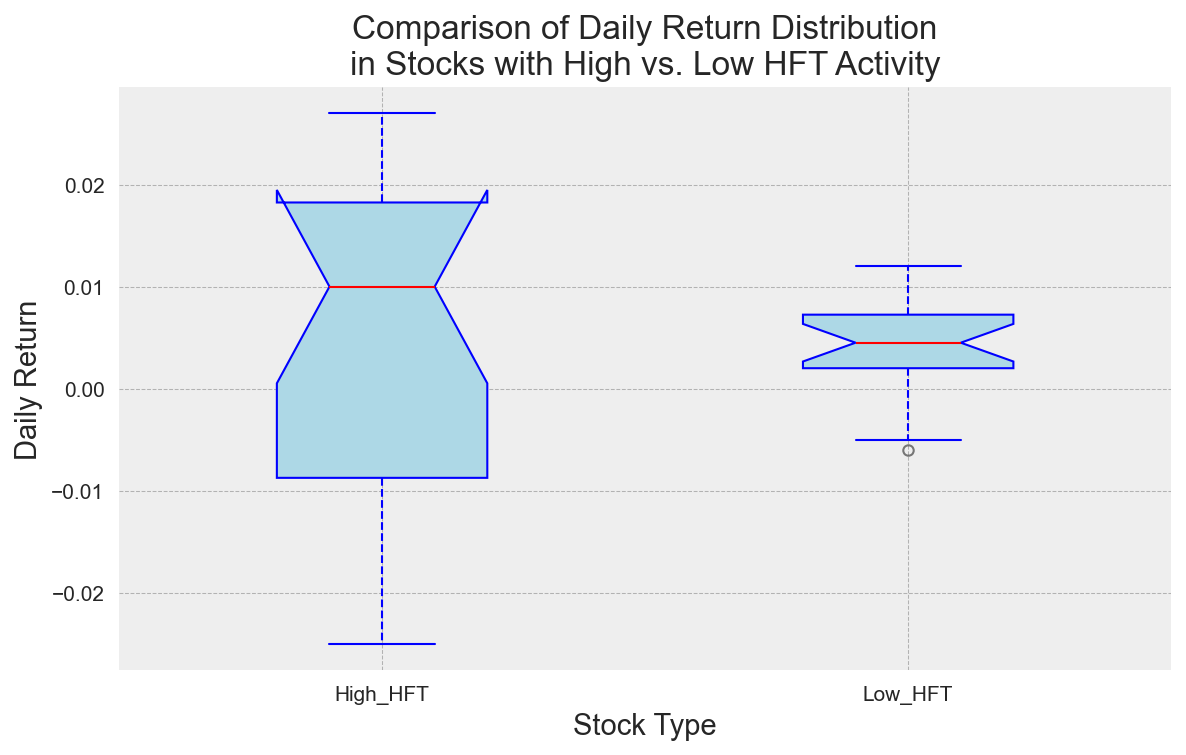What is the median daily return for stocks with high HFT activity? To determine the median daily return for stocks with high HFT activity, look at the red line within the box plot for "High HFT" stocks.
Answer: Around 0.014 Which stock type has a higher interquartile range (IQR) of daily returns? To find which stock type has a higher IQR, compare the height of the blue boxes. The IQR is the range between the bottom (25th percentile) and top (75th percentile) of the box.
Answer: High HFT What is the range of daily returns for stocks with low HFT activity? The range is determined by the minimum and maximum values represented by the tops and bottoms of the whiskers for the "Low HFT" stocks.
Answer: -0.006 to 0.012 Are there any outliers in the daily returns for stocks with high HFT activity? Look for points outside the whiskers for the "High HFT" box plot, marked by orange circles.
Answer: Yes How do the median daily returns compare between high and low HFT activity stocks? Observe the position of the red lines inside the boxes for both "High HFT" and "Low HFT" stocks.
Answer: Median is higher in High HFT What is the approximate median daily return for stocks with low HFT activity? Look at the red line inside the "Low HFT" box plot.
Answer: 0.005 Which stock type has a larger variance in daily returns? Larger variance is indicated by a wider spread in the whiskers and outliers. Compare the overall spread and outliers of both stock types.
Answer: High HFT What are the lowest and highest values of daily returns for stocks with high HFT activity? Identify the lowest point of the lower whisker and the highest point of the upper whisker for "High HFT" stocks.
Answer: -0.025 and 0.027 Do both stock types have any overlapping daily return values? Check if the ranges (from lower to upper whiskers) of both boxes intersect.
Answer: Yes Is the median daily return for high HFT activity stocks above zero? Look at the position of the red line in the "High HFT" box plot relative to the zero line.
Answer: Yes 